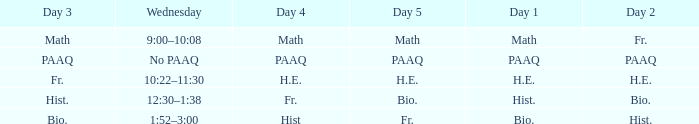What is the day 3 when day 4 is fr.? Hist. 